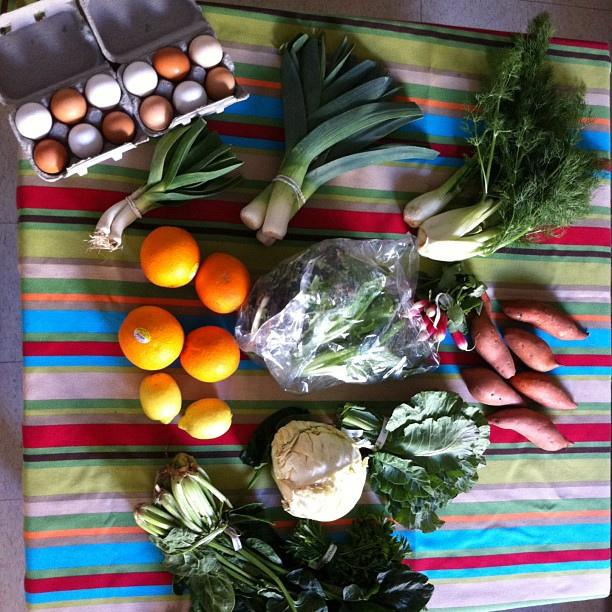What are the objects placed on? table 